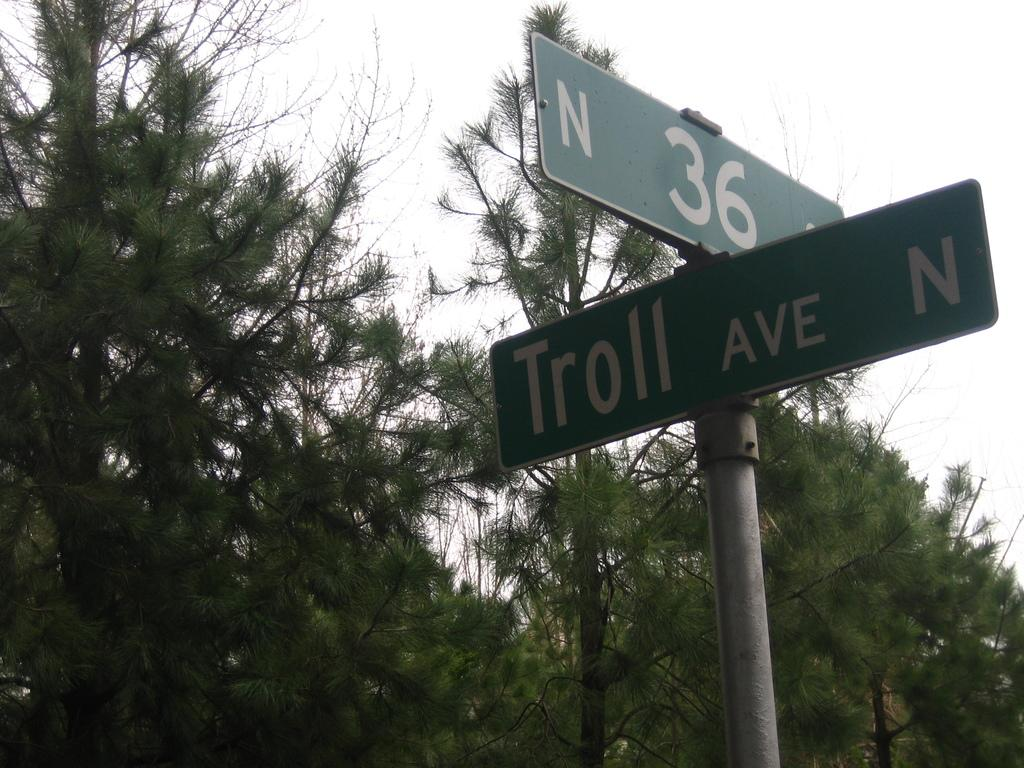What objects are attached to the pole in the image? There are two boards on a pole in the image. What can be seen in the background of the image? There are trees and the sky visible in the background of the image. How many cakes are on the ground in the image? There are no cakes present in the image. Can you describe the movement of the snail in the image? There is no snail present in the image, so it is not possible to describe its movement. 